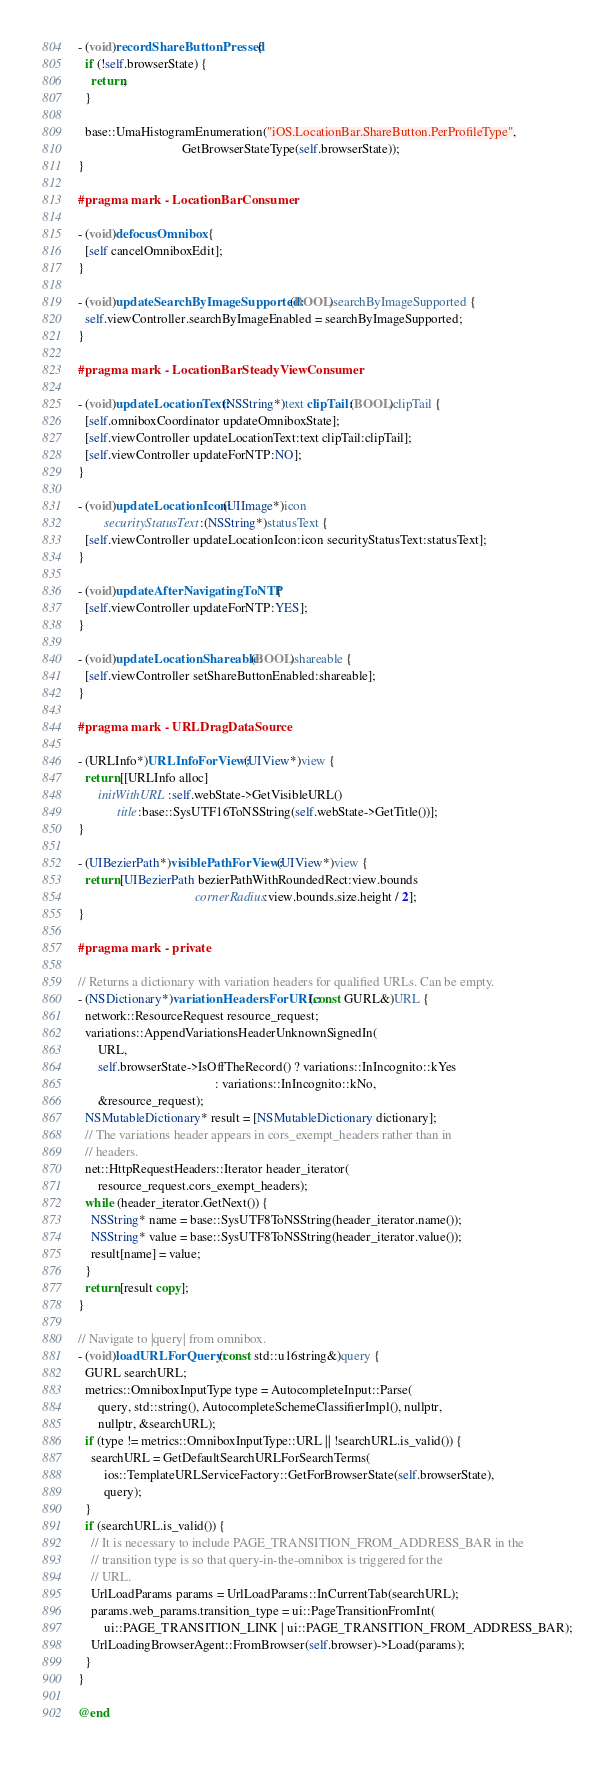<code> <loc_0><loc_0><loc_500><loc_500><_ObjectiveC_>- (void)recordShareButtonPressed {
  if (!self.browserState) {
    return;
  }

  base::UmaHistogramEnumeration("iOS.LocationBar.ShareButton.PerProfileType",
                                GetBrowserStateType(self.browserState));
}

#pragma mark - LocationBarConsumer

- (void)defocusOmnibox {
  [self cancelOmniboxEdit];
}

- (void)updateSearchByImageSupported:(BOOL)searchByImageSupported {
  self.viewController.searchByImageEnabled = searchByImageSupported;
}

#pragma mark - LocationBarSteadyViewConsumer

- (void)updateLocationText:(NSString*)text clipTail:(BOOL)clipTail {
  [self.omniboxCoordinator updateOmniboxState];
  [self.viewController updateLocationText:text clipTail:clipTail];
  [self.viewController updateForNTP:NO];
}

- (void)updateLocationIcon:(UIImage*)icon
        securityStatusText:(NSString*)statusText {
  [self.viewController updateLocationIcon:icon securityStatusText:statusText];
}

- (void)updateAfterNavigatingToNTP {
  [self.viewController updateForNTP:YES];
}

- (void)updateLocationShareable:(BOOL)shareable {
  [self.viewController setShareButtonEnabled:shareable];
}

#pragma mark - URLDragDataSource

- (URLInfo*)URLInfoForView:(UIView*)view {
  return [[URLInfo alloc]
      initWithURL:self.webState->GetVisibleURL()
            title:base::SysUTF16ToNSString(self.webState->GetTitle())];
}

- (UIBezierPath*)visiblePathForView:(UIView*)view {
  return [UIBezierPath bezierPathWithRoundedRect:view.bounds
                                    cornerRadius:view.bounds.size.height / 2];
}

#pragma mark - private

// Returns a dictionary with variation headers for qualified URLs. Can be empty.
- (NSDictionary*)variationHeadersForURL:(const GURL&)URL {
  network::ResourceRequest resource_request;
  variations::AppendVariationsHeaderUnknownSignedIn(
      URL,
      self.browserState->IsOffTheRecord() ? variations::InIncognito::kYes
                                          : variations::InIncognito::kNo,
      &resource_request);
  NSMutableDictionary* result = [NSMutableDictionary dictionary];
  // The variations header appears in cors_exempt_headers rather than in
  // headers.
  net::HttpRequestHeaders::Iterator header_iterator(
      resource_request.cors_exempt_headers);
  while (header_iterator.GetNext()) {
    NSString* name = base::SysUTF8ToNSString(header_iterator.name());
    NSString* value = base::SysUTF8ToNSString(header_iterator.value());
    result[name] = value;
  }
  return [result copy];
}

// Navigate to |query| from omnibox.
- (void)loadURLForQuery:(const std::u16string&)query {
  GURL searchURL;
  metrics::OmniboxInputType type = AutocompleteInput::Parse(
      query, std::string(), AutocompleteSchemeClassifierImpl(), nullptr,
      nullptr, &searchURL);
  if (type != metrics::OmniboxInputType::URL || !searchURL.is_valid()) {
    searchURL = GetDefaultSearchURLForSearchTerms(
        ios::TemplateURLServiceFactory::GetForBrowserState(self.browserState),
        query);
  }
  if (searchURL.is_valid()) {
    // It is necessary to include PAGE_TRANSITION_FROM_ADDRESS_BAR in the
    // transition type is so that query-in-the-omnibox is triggered for the
    // URL.
    UrlLoadParams params = UrlLoadParams::InCurrentTab(searchURL);
    params.web_params.transition_type = ui::PageTransitionFromInt(
        ui::PAGE_TRANSITION_LINK | ui::PAGE_TRANSITION_FROM_ADDRESS_BAR);
    UrlLoadingBrowserAgent::FromBrowser(self.browser)->Load(params);
  }
}

@end
</code> 